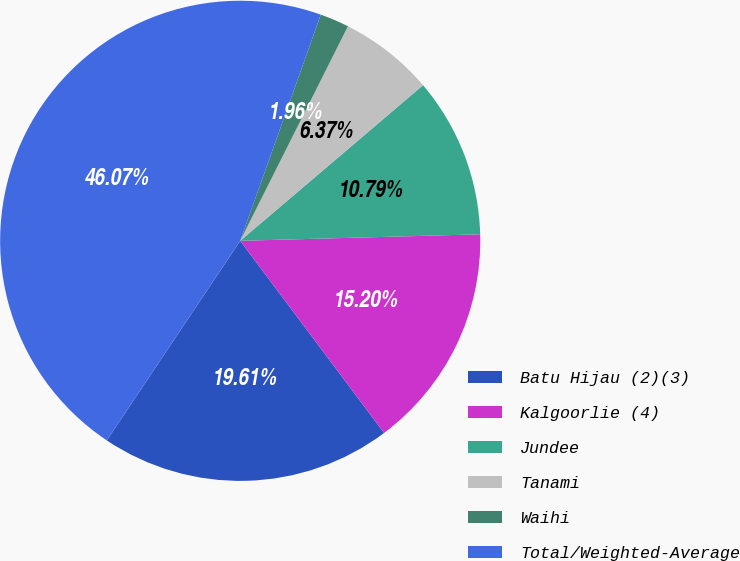<chart> <loc_0><loc_0><loc_500><loc_500><pie_chart><fcel>Batu Hijau (2)(3)<fcel>Kalgoorlie (4)<fcel>Jundee<fcel>Tanami<fcel>Waihi<fcel>Total/Weighted-Average<nl><fcel>19.61%<fcel>15.2%<fcel>10.79%<fcel>6.37%<fcel>1.96%<fcel>46.07%<nl></chart> 